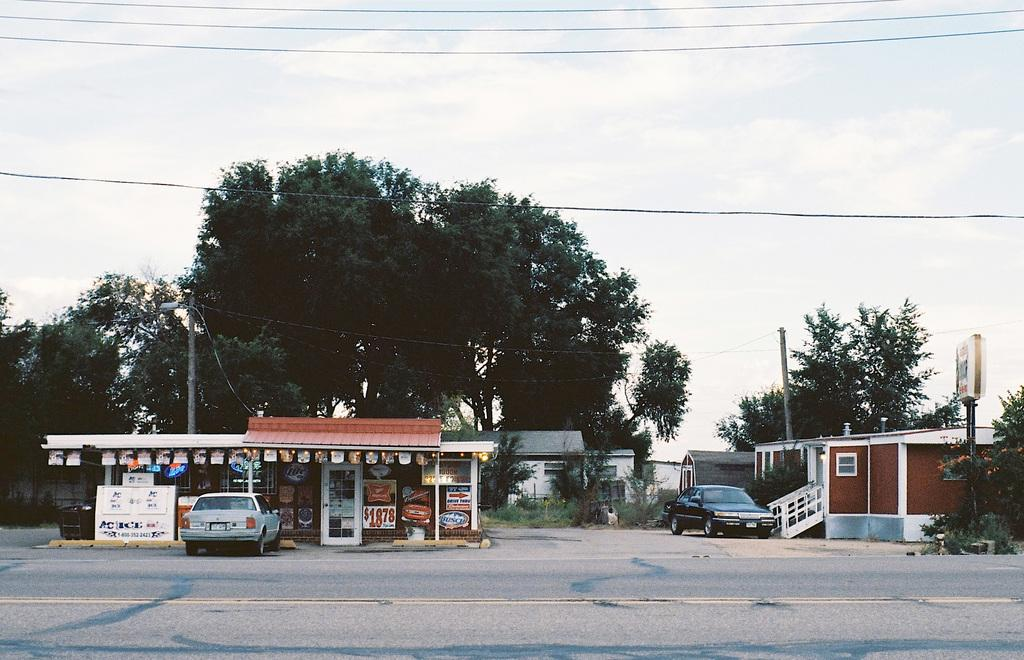What is the main feature of the image? The main feature of the image is a road. What can be seen traveling on the road? There are cars in the image. What type of structures are visible along the road? There are houses, a shed, and poles in the image. What additional items can be seen in the image? There are boards, posters, plants, trees, and wires in the image. What is the background of the image? The sky is visible in the background of the image, with clouds present. How many different types of objects are mentioned in the image? There are 12 different types of objects mentioned in the image. What type of shirt is being worn by the cows in the image? There are no cows present in the image, so it is not possible to determine what type of shirt they might be wearing. 